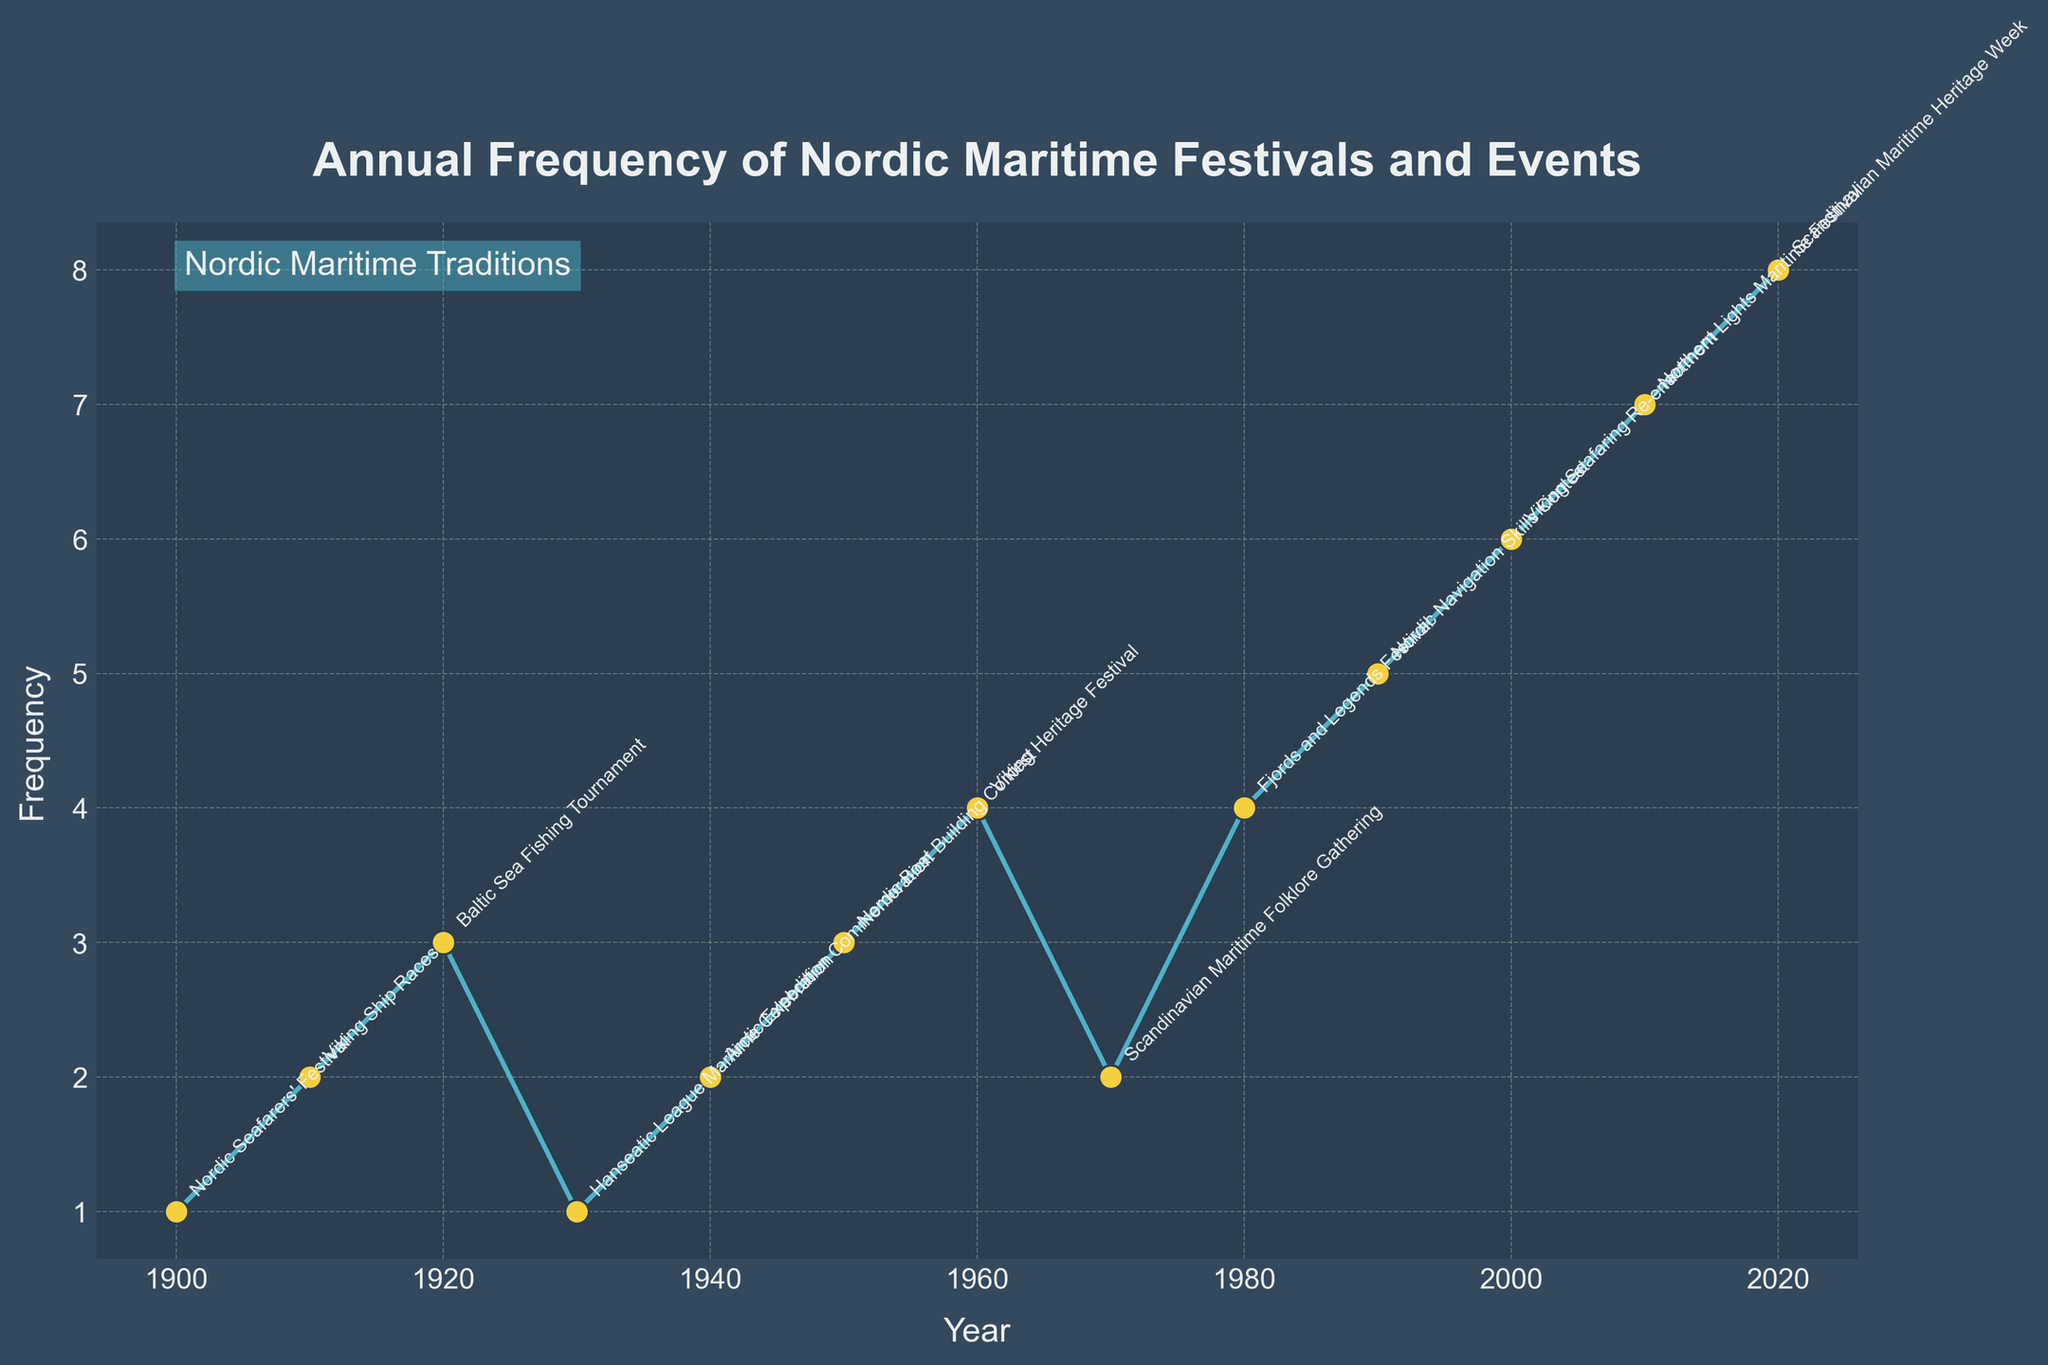What is the frequency of the Viking Heritage Festival in 1960? The figure labels the events for the year 1960, where the frequency is given next to each highlighted point. Looking at the year 1960, the Viking Heritage Festival is marked with a frequency of 4.
Answer: 4 Which year had the highest frequency of Nordic Maritime Festivals and Events? By examining the plot and looking for the peak point on the frequency axis, we see that the year 2020 has the highest frequency, which is 8.
Answer: 2020 How many events had a frequency of 3? From the annotated labels on the plot, we can count the number of points with a frequency of 3. We find points in the years 1920, 1950, and 1930, resulting in three events.
Answer: 3 What is the average frequency of the events from 1900 to 1950? We consider the frequencies from 1900 to 1950. Adding them gives: 1 (1900) + 2 (1910) + 3 (1920) + 1 (1930) + 2 (1940) + 3 (1950) = 12. There are 6 events, so the average frequency is 12 / 6 = 2.
Answer: 2 Did the frequency of events increase, decrease, or stay the same from 1990 to 2000? By comparing the frequencies for 1990 and 2000, we note: 5 in 1990 and 6 in 2000. This indicates an increase in frequency.
Answer: Increase Which event occurred in the year 1980 and what was its frequency? Looking at the year 1980 in the plot, we see the Fjords and Legends Festival marked with a frequency of 4.
Answer: Fjords and Legends Festival, 4 How does the frequency of the Viking Seafaring Re-enactment in 2000 compare with the frequency of the Northern Lights Maritime Festival in 2010? The plot indicates a frequency of 6 for the Viking Seafaring Re-enactment in 2000 and 7 for the Northern Lights Maritime Festival in 2010. Thus, 2010 has a higher frequency than 2000.
Answer: 2010 is higher Which event had the lowest frequency, and when did it occur? Identifying the smallest value on the frequency axis, we see values marked as 1. The events "Nordic Seafarers' Festival" in 1900 and "Hanseatic League Maritime Celebration" in 1930 both have a frequency of 1, as the lowest.
Answer: Nordic Seafarers' Festival 1900, Hanseatic League Maritime Celebration 1930 What is the total frequency of events for the years 1970, 1980, and 1990 combined? Summing the frequencies from the plot, we get: 2 (1970) + 4 (1980) + 5 (1990) = 11.
Answer: 11 